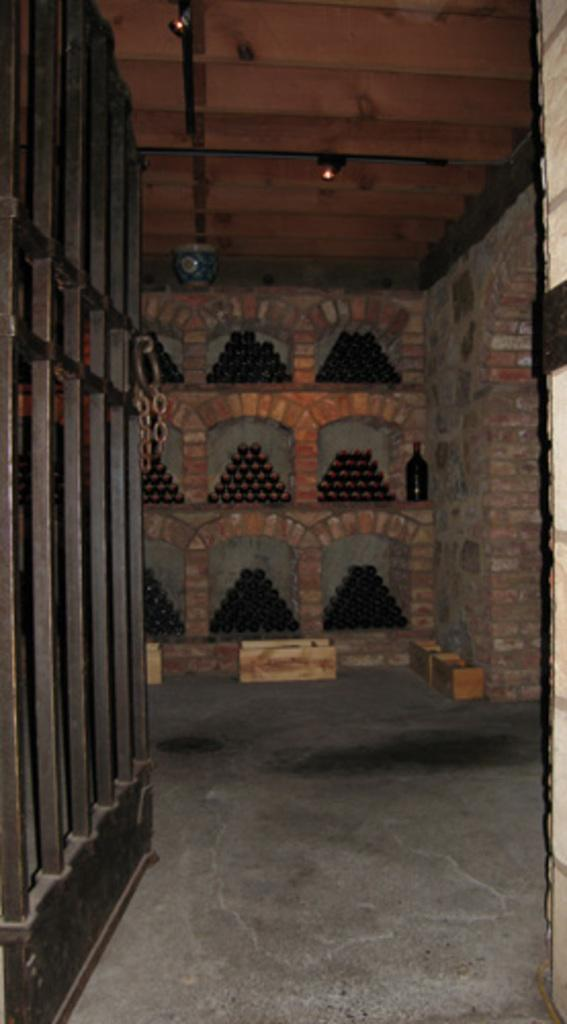What structure can be seen in the image? There is a gate in the image. What is the surface that the gate is standing on? There is a floor in the image. What can be seen in the background of the image? There are objects on shelves and a bottle in the background. What is illuminating the area in the image? Lights are visible at the top of the image. What thought is the gate having in the image? The gate is an inanimate object and does not have thoughts. --- Facts: 1. There is a person sitting on a chair in the image. 2. The person is holding a book. 3. There is a table next to the chair. 4. There is a lamp on the table. 5. The background of the image is a room. Absurd Topics: elephant, ocean, dance Conversation: What is the person in the image doing? The person is sitting on a chair in the image. What object is the person holding? The person is holding a book. What is located next to the chair? There is a table next to the chair. What is on the table? There is a lamp on the table. What is the setting of the image? The background of the image is a room. Reasoning: Let's think step by step in order to produce the conversation. We start by identifying the person's action in the image, which is sitting on a chair. Then, we describe the object the person is holding, which is a book. Next, we mention the table that is located next to the chair and the lamp that is on the table. Finally, we describe the setting of the image, which is a room. Absurd Question/Answer: Can you see any elephants swimming in the ocean in the image? No, there are no elephants or ocean present in the image. 